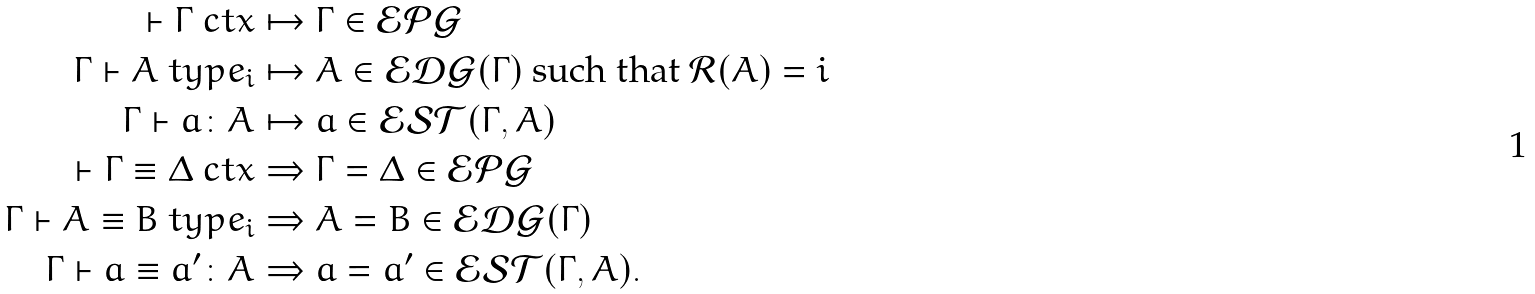Convert formula to latex. <formula><loc_0><loc_0><loc_500><loc_500>\vdash \Gamma \ c t x & \mapsto \Gamma \in \mathcal { E P G } \\ \Gamma \vdash A \ t y p e _ { i } & \mapsto A \in \mathcal { E D G } ( \Gamma ) \ \text {such that $\mathcal{R}(A) = i$} \\ \Gamma \vdash a \colon A & \mapsto a \in \mathcal { E S T } ( \Gamma , A ) \\ \vdash \Gamma \equiv \Delta \ c t x & \Rightarrow \Gamma = \Delta \in \mathcal { E P G } \\ \Gamma \vdash A \equiv B \ t y p e _ { i } & \Rightarrow A = B \in \mathcal { E D G } ( \Gamma ) \\ \Gamma \vdash a \equiv a ^ { \prime } \colon A & \Rightarrow a = a ^ { \prime } \in \mathcal { E S T } ( \Gamma , A ) .</formula> 